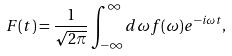<formula> <loc_0><loc_0><loc_500><loc_500>F ( t ) = \frac { 1 } { \sqrt { 2 \pi } } \int _ { - \infty } ^ { \infty } d \omega f ( \omega ) e ^ { - i { \omega } t } ,</formula> 